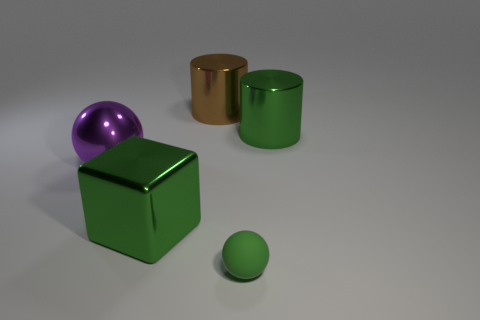Add 3 large brown things. How many objects exist? 8 Subtract all cylinders. How many objects are left? 3 Subtract all purple spheres. Subtract all metal blocks. How many objects are left? 3 Add 3 large metallic cubes. How many large metallic cubes are left? 4 Add 5 large brown shiny cylinders. How many large brown shiny cylinders exist? 6 Subtract 0 yellow cubes. How many objects are left? 5 